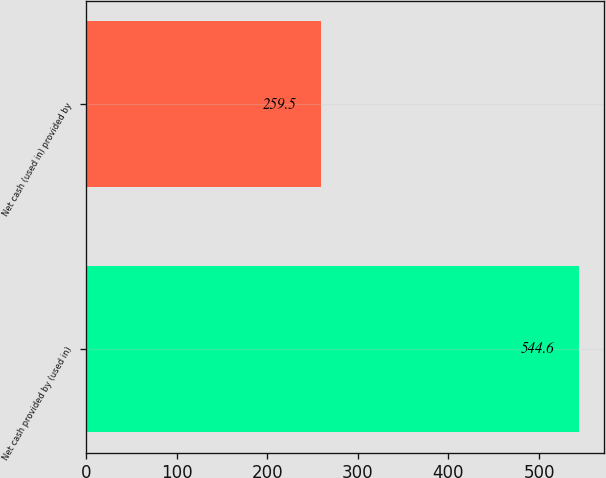Convert chart. <chart><loc_0><loc_0><loc_500><loc_500><bar_chart><fcel>Net cash provided by (used in)<fcel>Net cash (used in) provided by<nl><fcel>544.6<fcel>259.5<nl></chart> 